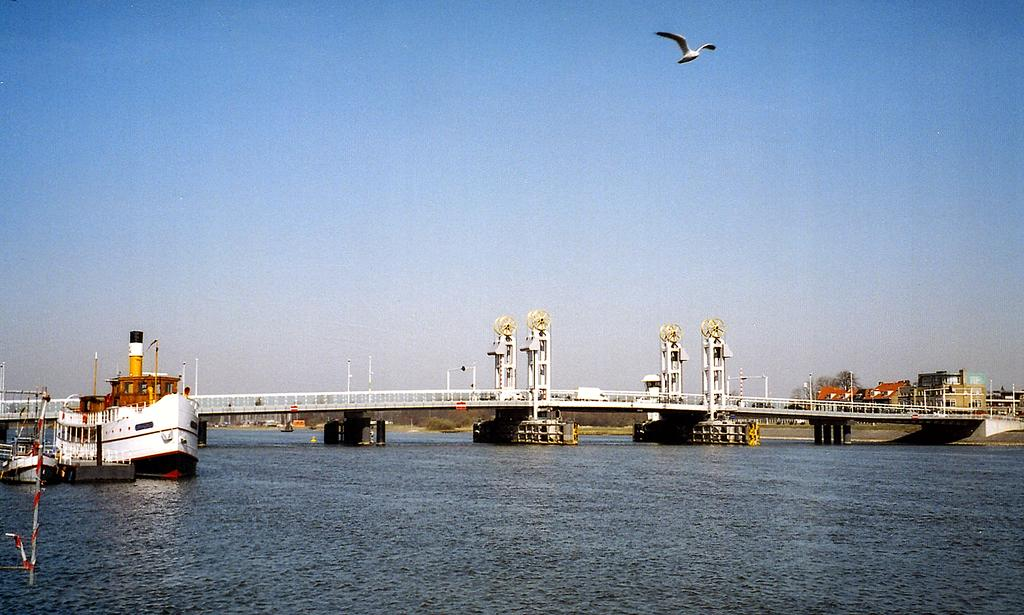What is the main subject of the image? There is a ship in the image. What structures can be seen in the image? There are poles and a bridge in the image. What other objects are present in the image? There are other objects in the image, but their specific details are not mentioned in the facts. What is visible at the top of the image? The sky is visible at the top of the image. What is flying in the sky? There is a bird in the sky. What is visible at the bottom of the image? There is water visible at the bottom of the image. What type of shirt is the table wearing in the image? There is no table or shirt present in the image. What kind of cracker is floating on the water in the image? There is no cracker present in the image. 